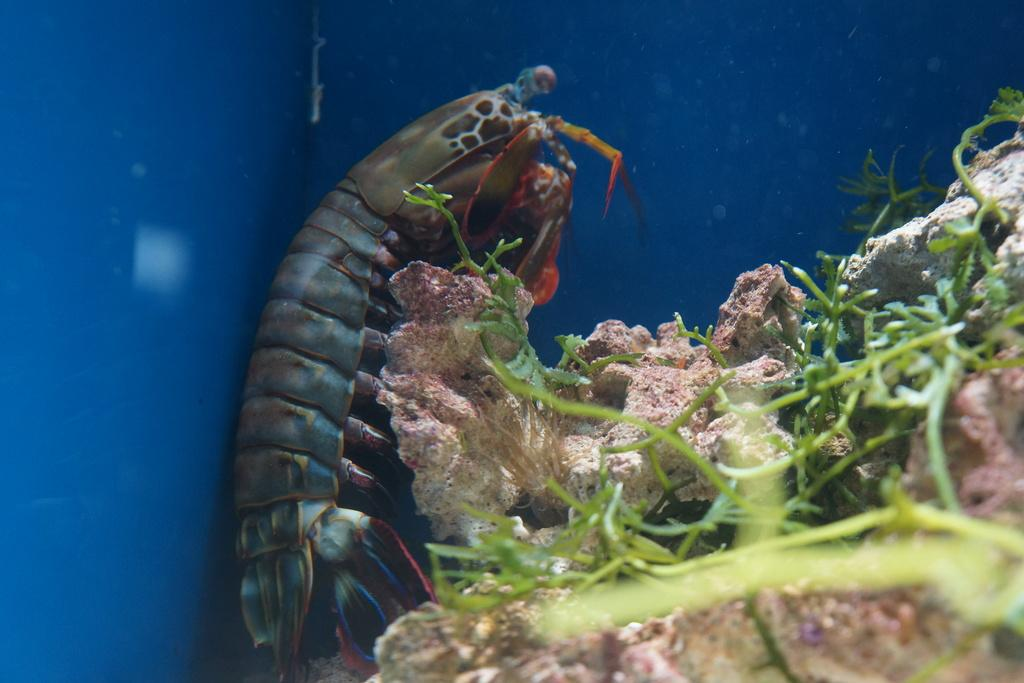What type of seafood is present in the image? There are shrimp in the image. What other elements can be seen in the image besides the shrimp? There are plants in the image. What route does the fireman take to reach the linen in the image? There is no fireman or linen present in the image, so it is not possible to determine a route. 